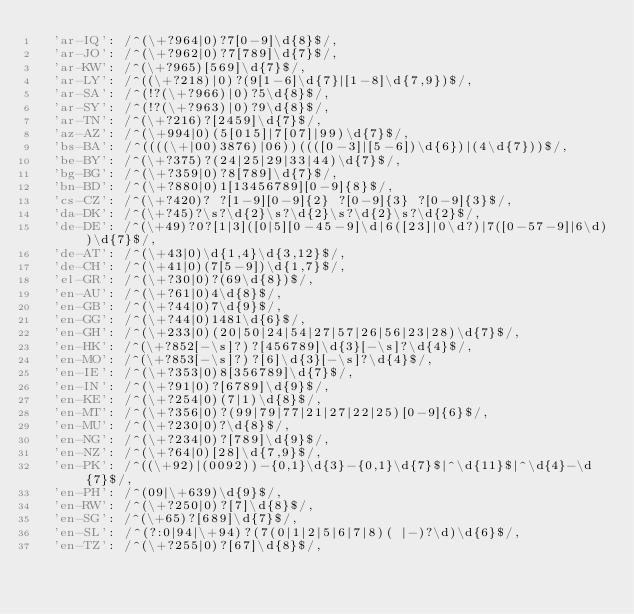Convert code to text. <code><loc_0><loc_0><loc_500><loc_500><_JavaScript_>  'ar-IQ': /^(\+?964|0)?7[0-9]\d{8}$/,
  'ar-JO': /^(\+?962|0)?7[789]\d{7}$/,
  'ar-KW': /^(\+?965)[569]\d{7}$/,
  'ar-LY': /^((\+?218)|0)?(9[1-6]\d{7}|[1-8]\d{7,9})$/,
  'ar-SA': /^(!?(\+?966)|0)?5\d{8}$/,
  'ar-SY': /^(!?(\+?963)|0)?9\d{8}$/,
  'ar-TN': /^(\+?216)?[2459]\d{7}$/,
  'az-AZ': /^(\+994|0)(5[015]|7[07]|99)\d{7}$/,
  'bs-BA': /^((((\+|00)3876)|06))((([0-3]|[5-6])\d{6})|(4\d{7}))$/,
  'be-BY': /^(\+?375)?(24|25|29|33|44)\d{7}$/,
  'bg-BG': /^(\+?359|0)?8[789]\d{7}$/,
  'bn-BD': /^(\+?880|0)1[13456789][0-9]{8}$/,
  'cs-CZ': /^(\+?420)? ?[1-9][0-9]{2} ?[0-9]{3} ?[0-9]{3}$/,
  'da-DK': /^(\+?45)?\s?\d{2}\s?\d{2}\s?\d{2}\s?\d{2}$/,
  'de-DE': /^(\+49)?0?[1|3]([0|5][0-45-9]\d|6([23]|0\d?)|7([0-57-9]|6\d))\d{7}$/,
  'de-AT': /^(\+43|0)\d{1,4}\d{3,12}$/,
  'de-CH': /^(\+41|0)(7[5-9])\d{1,7}$/,
  'el-GR': /^(\+?30|0)?(69\d{8})$/,
  'en-AU': /^(\+?61|0)4\d{8}$/,
  'en-GB': /^(\+?44|0)7\d{9}$/,
  'en-GG': /^(\+?44|0)1481\d{6}$/,
  'en-GH': /^(\+233|0)(20|50|24|54|27|57|26|56|23|28)\d{7}$/,
  'en-HK': /^(\+?852[-\s]?)?[456789]\d{3}[-\s]?\d{4}$/,
  'en-MO': /^(\+?853[-\s]?)?[6]\d{3}[-\s]?\d{4}$/,
  'en-IE': /^(\+?353|0)8[356789]\d{7}$/,
  'en-IN': /^(\+?91|0)?[6789]\d{9}$/,
  'en-KE': /^(\+?254|0)(7|1)\d{8}$/,
  'en-MT': /^(\+?356|0)?(99|79|77|21|27|22|25)[0-9]{6}$/,
  'en-MU': /^(\+?230|0)?\d{8}$/,
  'en-NG': /^(\+?234|0)?[789]\d{9}$/,
  'en-NZ': /^(\+?64|0)[28]\d{7,9}$/,
  'en-PK': /^((\+92)|(0092))-{0,1}\d{3}-{0,1}\d{7}$|^\d{11}$|^\d{4}-\d{7}$/,
  'en-PH': /^(09|\+639)\d{9}$/,
  'en-RW': /^(\+?250|0)?[7]\d{8}$/,
  'en-SG': /^(\+65)?[689]\d{7}$/,
  'en-SL': /^(?:0|94|\+94)?(7(0|1|2|5|6|7|8)( |-)?\d)\d{6}$/,
  'en-TZ': /^(\+?255|0)?[67]\d{8}$/,</code> 